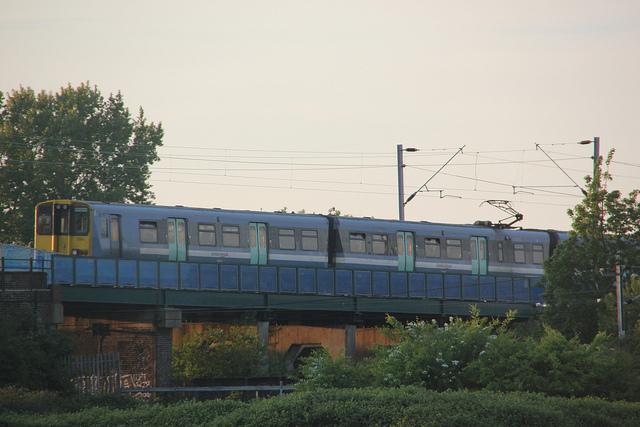What is constructed under the bridge?
Be succinct. Wall. Is it day or nighttime?
Quick response, please. Day. Are the train's windows all the same size?
Be succinct. No. What is written on the train cars?
Give a very brief answer. Nothing. Could this engine be steam powered?
Short answer required. No. What is the railing for?
Be succinct. Train. What is the train number?
Give a very brief answer. 1. Can you see the sky?
Keep it brief. Yes. What color is the M on the graffiti?
Be succinct. White. Is it a sunny day?
Quick response, please. No. What power source runs the train?
Give a very brief answer. Electricity. How long is the train?
Give a very brief answer. 3 cars. What color is the train?
Give a very brief answer. Blue. Is this train prepared for climbing terrain?
Quick response, please. No. How many boxcars are visible?
Quick response, please. 2. What kind of train is this?
Keep it brief. Passenger. What year is denoted by the train?
Answer briefly. 1980. Where is the bridge?
Be succinct. Under train. 